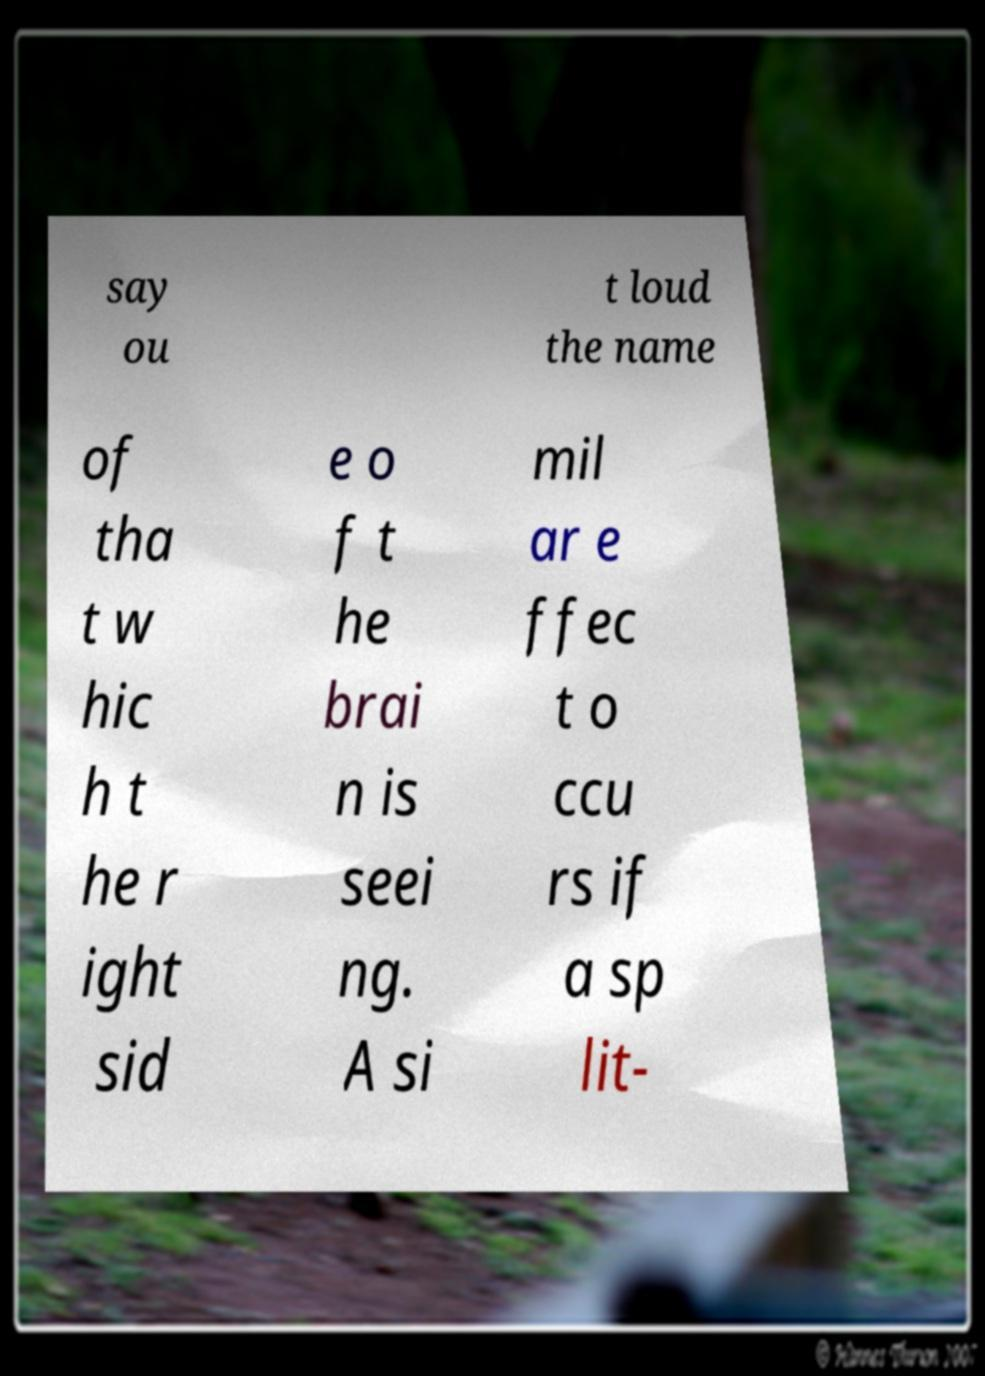Can you read and provide the text displayed in the image?This photo seems to have some interesting text. Can you extract and type it out for me? say ou t loud the name of tha t w hic h t he r ight sid e o f t he brai n is seei ng. A si mil ar e ffec t o ccu rs if a sp lit- 